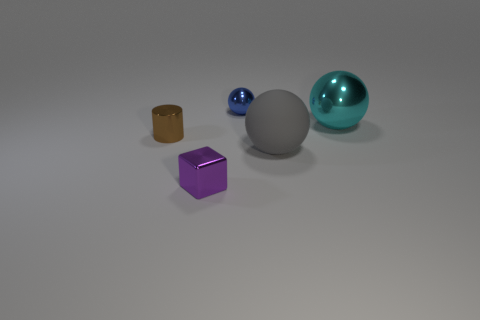Are there any other metallic things of the same shape as the large cyan metallic object?
Make the answer very short. Yes. There is a small object behind the small metallic thing to the left of the tiny cube; what number of shiny objects are right of it?
Make the answer very short. 1. Does the rubber ball have the same color as the tiny shiny object that is in front of the small brown thing?
Offer a terse response. No. How many objects are shiny things that are in front of the tiny cylinder or tiny cubes that are in front of the gray object?
Offer a terse response. 1. Are there more tiny brown metal cylinders in front of the large gray sphere than tiny shiny things that are behind the cyan metallic object?
Give a very brief answer. No. What material is the sphere that is in front of the brown metal thing on the left side of the big thing that is in front of the cyan metallic ball?
Your response must be concise. Rubber. Does the shiny object right of the small blue metallic ball have the same shape as the small thing behind the small brown cylinder?
Offer a very short reply. Yes. Is there a brown metallic thing of the same size as the cyan sphere?
Provide a short and direct response. No. What number of brown objects are either small metal cylinders or big shiny things?
Offer a terse response. 1. How many tiny cubes have the same color as the metal cylinder?
Provide a succinct answer. 0. 